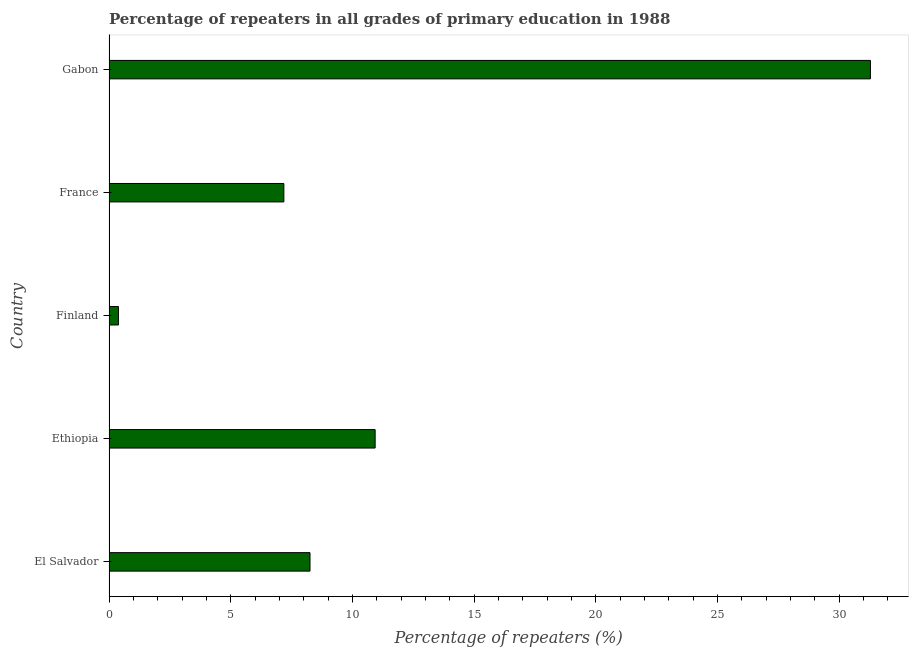Does the graph contain any zero values?
Your answer should be very brief. No. Does the graph contain grids?
Your response must be concise. No. What is the title of the graph?
Keep it short and to the point. Percentage of repeaters in all grades of primary education in 1988. What is the label or title of the X-axis?
Offer a very short reply. Percentage of repeaters (%). What is the percentage of repeaters in primary education in El Salvador?
Make the answer very short. 8.26. Across all countries, what is the maximum percentage of repeaters in primary education?
Keep it short and to the point. 31.28. Across all countries, what is the minimum percentage of repeaters in primary education?
Make the answer very short. 0.39. In which country was the percentage of repeaters in primary education maximum?
Give a very brief answer. Gabon. In which country was the percentage of repeaters in primary education minimum?
Keep it short and to the point. Finland. What is the sum of the percentage of repeaters in primary education?
Provide a succinct answer. 58.04. What is the difference between the percentage of repeaters in primary education in Finland and Gabon?
Keep it short and to the point. -30.89. What is the average percentage of repeaters in primary education per country?
Provide a short and direct response. 11.61. What is the median percentage of repeaters in primary education?
Provide a short and direct response. 8.26. In how many countries, is the percentage of repeaters in primary education greater than 24 %?
Offer a terse response. 1. What is the ratio of the percentage of repeaters in primary education in El Salvador to that in Finland?
Make the answer very short. 21.36. Is the difference between the percentage of repeaters in primary education in France and Gabon greater than the difference between any two countries?
Keep it short and to the point. No. What is the difference between the highest and the second highest percentage of repeaters in primary education?
Offer a very short reply. 20.35. Is the sum of the percentage of repeaters in primary education in Ethiopia and France greater than the maximum percentage of repeaters in primary education across all countries?
Make the answer very short. No. What is the difference between the highest and the lowest percentage of repeaters in primary education?
Offer a terse response. 30.89. What is the difference between two consecutive major ticks on the X-axis?
Your response must be concise. 5. What is the Percentage of repeaters (%) of El Salvador?
Your answer should be compact. 8.26. What is the Percentage of repeaters (%) in Ethiopia?
Your answer should be compact. 10.93. What is the Percentage of repeaters (%) in Finland?
Your answer should be compact. 0.39. What is the Percentage of repeaters (%) of France?
Your response must be concise. 7.18. What is the Percentage of repeaters (%) of Gabon?
Ensure brevity in your answer.  31.28. What is the difference between the Percentage of repeaters (%) in El Salvador and Ethiopia?
Keep it short and to the point. -2.68. What is the difference between the Percentage of repeaters (%) in El Salvador and Finland?
Your answer should be compact. 7.87. What is the difference between the Percentage of repeaters (%) in El Salvador and France?
Ensure brevity in your answer.  1.07. What is the difference between the Percentage of repeaters (%) in El Salvador and Gabon?
Offer a very short reply. -23.02. What is the difference between the Percentage of repeaters (%) in Ethiopia and Finland?
Offer a very short reply. 10.55. What is the difference between the Percentage of repeaters (%) in Ethiopia and France?
Offer a very short reply. 3.75. What is the difference between the Percentage of repeaters (%) in Ethiopia and Gabon?
Ensure brevity in your answer.  -20.35. What is the difference between the Percentage of repeaters (%) in Finland and France?
Your answer should be very brief. -6.8. What is the difference between the Percentage of repeaters (%) in Finland and Gabon?
Give a very brief answer. -30.89. What is the difference between the Percentage of repeaters (%) in France and Gabon?
Offer a terse response. -24.1. What is the ratio of the Percentage of repeaters (%) in El Salvador to that in Ethiopia?
Provide a succinct answer. 0.76. What is the ratio of the Percentage of repeaters (%) in El Salvador to that in Finland?
Offer a very short reply. 21.36. What is the ratio of the Percentage of repeaters (%) in El Salvador to that in France?
Offer a very short reply. 1.15. What is the ratio of the Percentage of repeaters (%) in El Salvador to that in Gabon?
Ensure brevity in your answer.  0.26. What is the ratio of the Percentage of repeaters (%) in Ethiopia to that in Finland?
Provide a succinct answer. 28.28. What is the ratio of the Percentage of repeaters (%) in Ethiopia to that in France?
Offer a very short reply. 1.52. What is the ratio of the Percentage of repeaters (%) in Ethiopia to that in Gabon?
Your response must be concise. 0.35. What is the ratio of the Percentage of repeaters (%) in Finland to that in France?
Offer a very short reply. 0.05. What is the ratio of the Percentage of repeaters (%) in Finland to that in Gabon?
Offer a terse response. 0.01. What is the ratio of the Percentage of repeaters (%) in France to that in Gabon?
Keep it short and to the point. 0.23. 